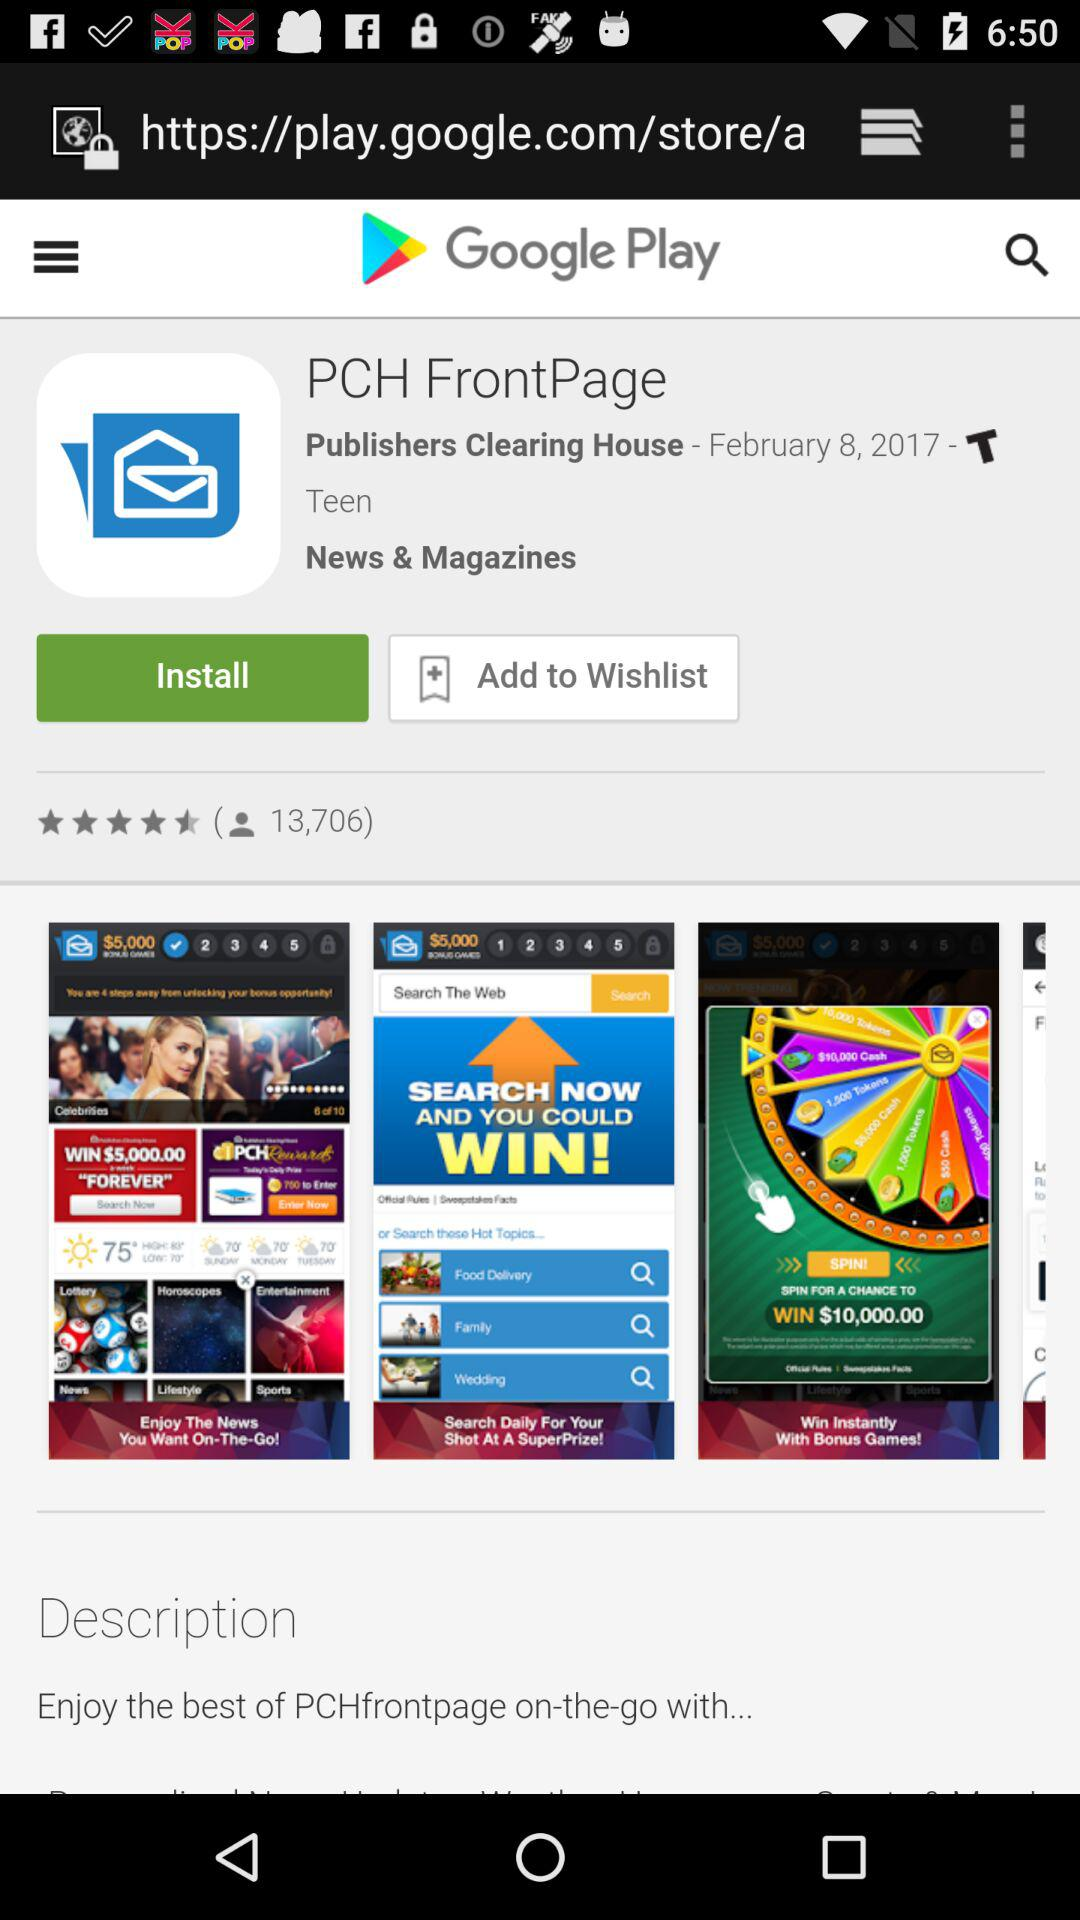What is the rating? The rating is 4.5 stars. 